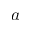<formula> <loc_0><loc_0><loc_500><loc_500>a</formula> 